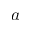<formula> <loc_0><loc_0><loc_500><loc_500>a</formula> 